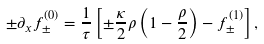Convert formula to latex. <formula><loc_0><loc_0><loc_500><loc_500>\pm \partial _ { x } f ^ { ( 0 ) } _ { \pm } = \frac { 1 } { \tau } \left [ \pm \frac { \kappa } { 2 } \rho \left ( 1 - \frac { \rho } { 2 } \right ) - f ^ { ( 1 ) } _ { \pm } \right ] ,</formula> 